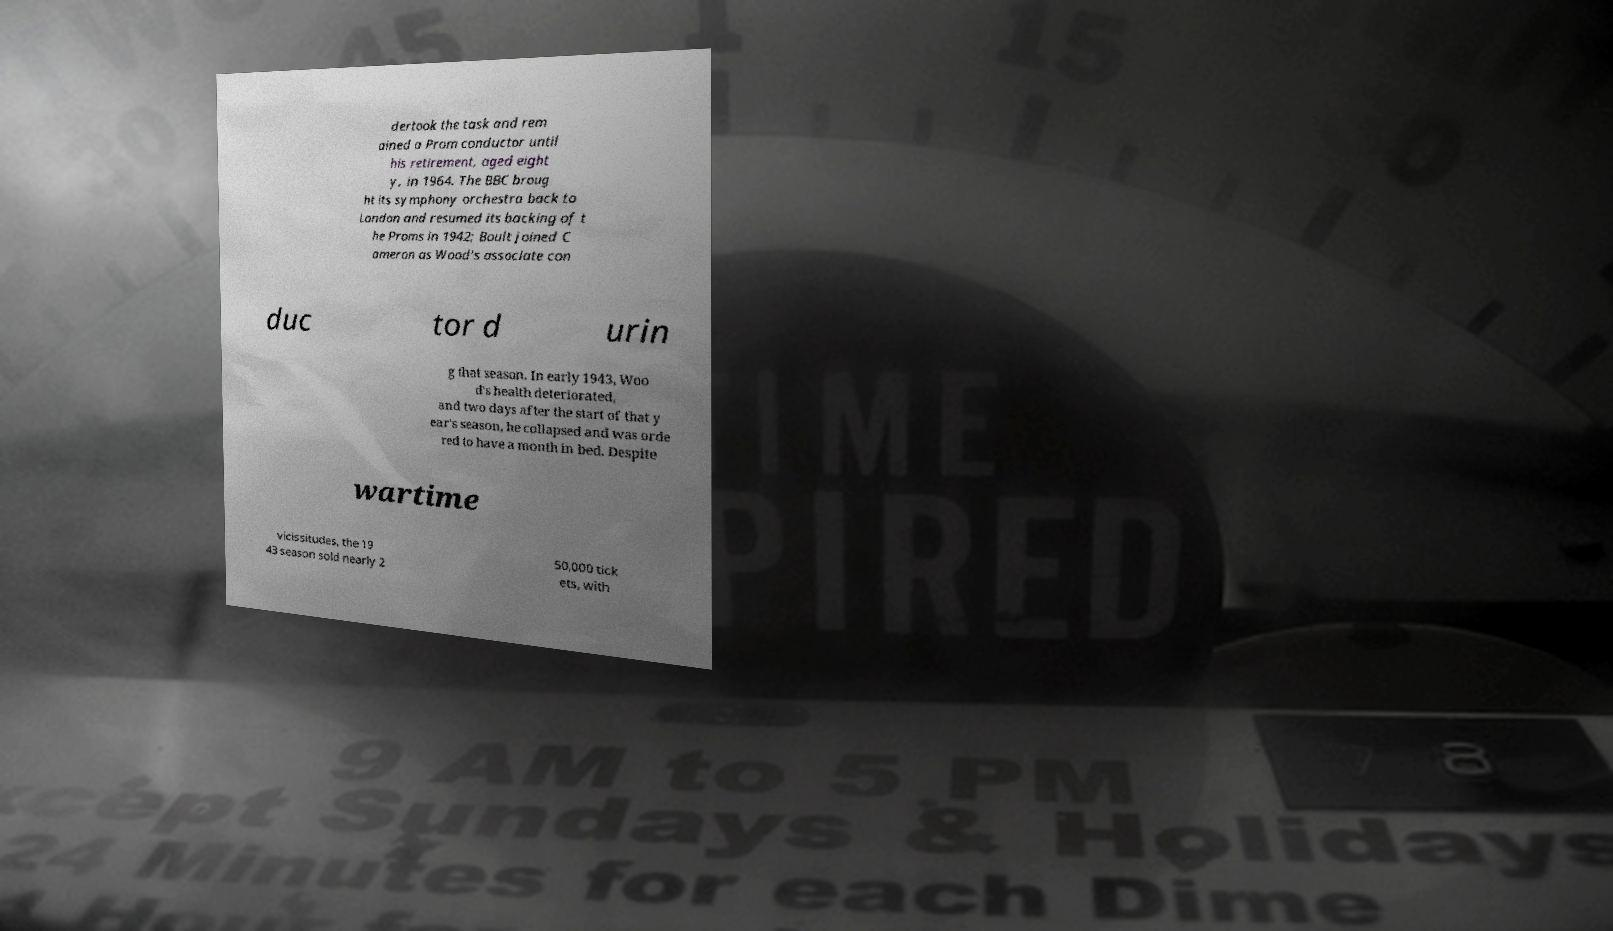Please identify and transcribe the text found in this image. dertook the task and rem ained a Prom conductor until his retirement, aged eight y, in 1964. The BBC broug ht its symphony orchestra back to London and resumed its backing of t he Proms in 1942; Boult joined C ameron as Wood's associate con duc tor d urin g that season. In early 1943, Woo d's health deteriorated, and two days after the start of that y ear's season, he collapsed and was orde red to have a month in bed. Despite wartime vicissitudes, the 19 43 season sold nearly 2 50,000 tick ets, with 